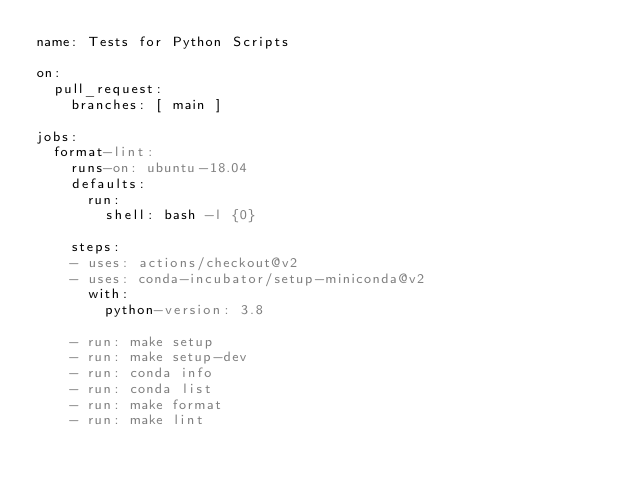<code> <loc_0><loc_0><loc_500><loc_500><_YAML_>name: Tests for Python Scripts

on:
  pull_request:
    branches: [ main ]

jobs:
  format-lint:
    runs-on: ubuntu-18.04
    defaults:
      run:
        shell: bash -l {0}

    steps:
    - uses: actions/checkout@v2
    - uses: conda-incubator/setup-miniconda@v2
      with:
        python-version: 3.8

    - run: make setup
    - run: make setup-dev
    - run: conda info
    - run: conda list
    - run: make format
    - run: make lint
</code> 